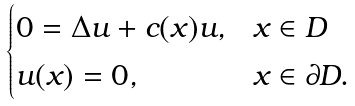Convert formula to latex. <formula><loc_0><loc_0><loc_500><loc_500>\begin{cases} 0 = { \Delta } u + c ( x ) u , & x \in D \\ u ( x ) = 0 , & x \in \partial D . \end{cases}</formula> 